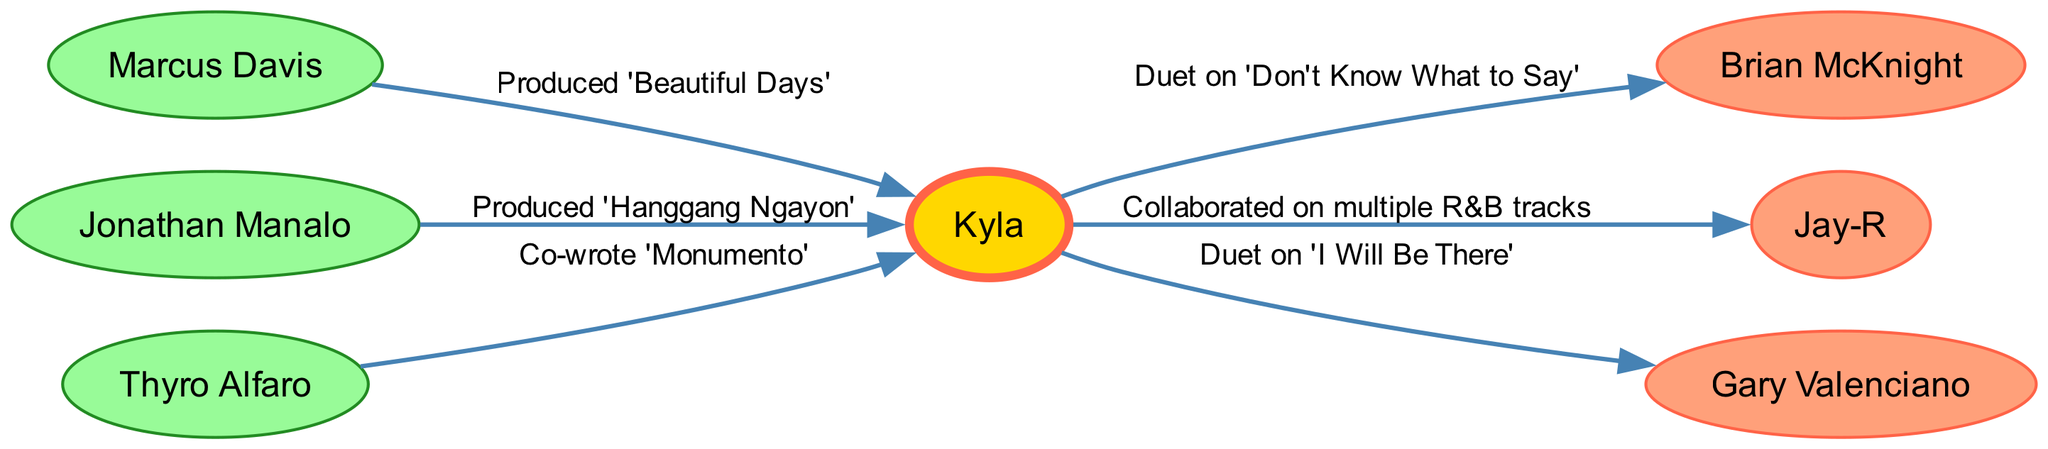What is Kyla's first collaboration listed in the diagram? The diagram shows the edges originating from Kyla, and the first collaboration listed is with Brian McKnight on the track 'Don't Know What to Say'.
Answer: 'Don't Know What to Say' Who produced the song 'Beautiful Days' for Kyla? In the diagram, there is a directed edge pointing from Marcus Davis to Kyla, indicating that Marcus Davis is responsible for producing the song 'Beautiful Days'.
Answer: Marcus Davis How many artists has Kyla collaborated with in total according to the diagram? By counting the nodes directly linked to Kyla, the artists are Brian McKnight, Jay-R, and Gary Valenciano which gives a total of 3 unique artists when considering the edges.
Answer: 3 What is the relationship between Kyla and Thyro Alfaro in the diagram? The edge from Thyro Alfaro to Kyla indicates that they have a collaborative relationship where Thyro Alfaro co-wrote the song 'Monumento', which defines the nature of their connection.
Answer: Co-wrote 'Monumento' Which producer is connected to Kyla for the song 'Hanggang Ngayon'? The diagram shows a directed edge from Jonathan Manalo to Kyla, specifically indicating that Jonathan Manalo produced the song 'Hanggang Ngayon'.
Answer: Jonathan Manalo How many total nodes are in the diagram? The diagram lists a total of 7 nodes: Kyla, Brian McKnight, Jay-R, Marcus Davis, Jonathan Manalo, Thyro Alfaro, and Gary Valenciano, which sums up to 7 distinct entities in the graph.
Answer: 7 What type of relationship does Kyla have with Gary Valenciano? The edge from Kyla to Gary Valenciano signifies a duet collaboration on the song 'I Will Be There', clearly highlighting the nature of their relationship.
Answer: Duet on 'I Will Be There' Which artist collaborates with Kyla on multiple tracks? The label on the edge connecting Jay-R to Kyla specifies that they have collaborated on multiple R&B tracks, establishing the collaboration's breadth.
Answer: Jay-R 